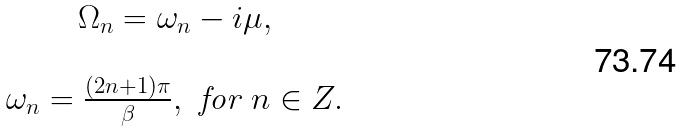<formula> <loc_0><loc_0><loc_500><loc_500>\begin{array} { c } \Omega _ { n } = \omega _ { n } - i \mu , \\ \\ \omega _ { n } = \frac { ( 2 n + 1 ) \pi } \beta , \text { for } n \in { Z . } \end{array}</formula> 